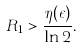Convert formula to latex. <formula><loc_0><loc_0><loc_500><loc_500>R _ { 1 } > \frac { \eta ( \epsilon ) } { \ln 2 } .</formula> 